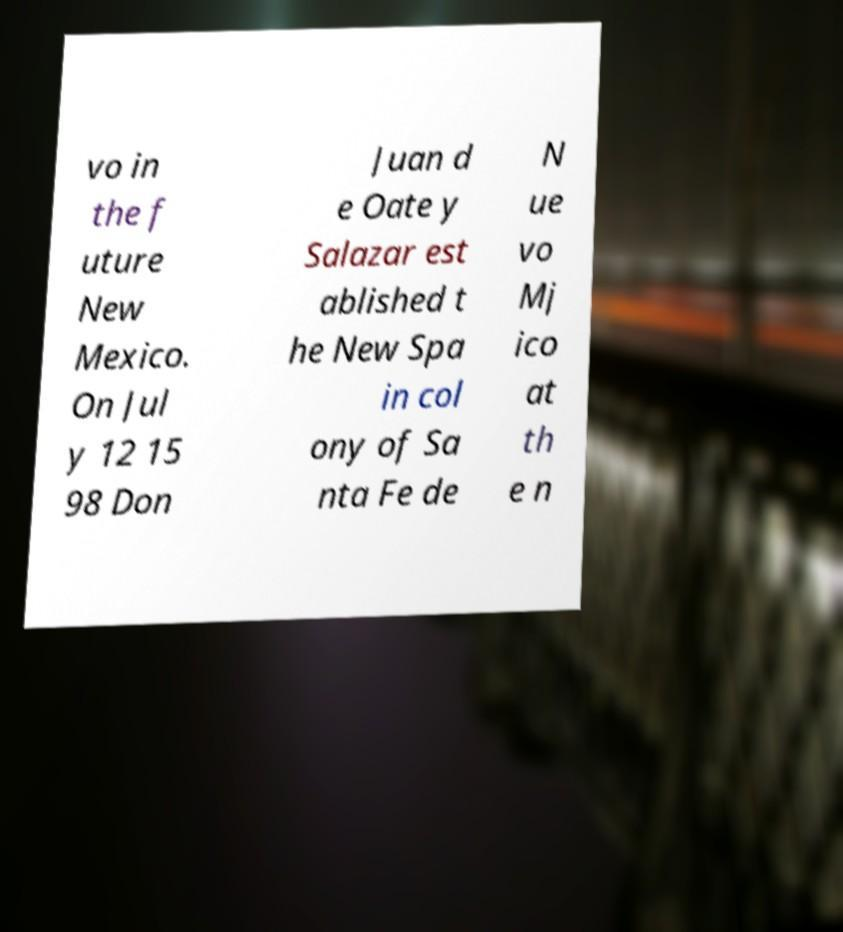Could you extract and type out the text from this image? vo in the f uture New Mexico. On Jul y 12 15 98 Don Juan d e Oate y Salazar est ablished t he New Spa in col ony of Sa nta Fe de N ue vo Mj ico at th e n 